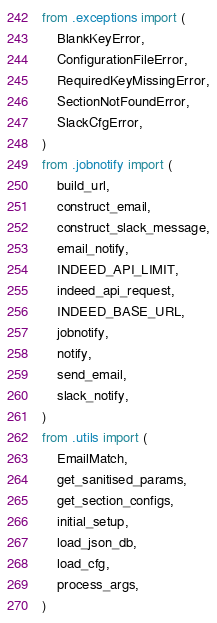<code> <loc_0><loc_0><loc_500><loc_500><_Python_>from .exceptions import (
    BlankKeyError,
    ConfigurationFileError,
    RequiredKeyMissingError,
    SectionNotFoundError,
    SlackCfgError,
)
from .jobnotify import (
    build_url,
    construct_email,
    construct_slack_message,
    email_notify,
    INDEED_API_LIMIT,
    indeed_api_request,
    INDEED_BASE_URL,
    jobnotify,
    notify,
    send_email,
    slack_notify,
)
from .utils import (
    EmailMatch,
    get_sanitised_params,
    get_section_configs,
    initial_setup,
    load_json_db,
    load_cfg,
    process_args,
)
</code> 